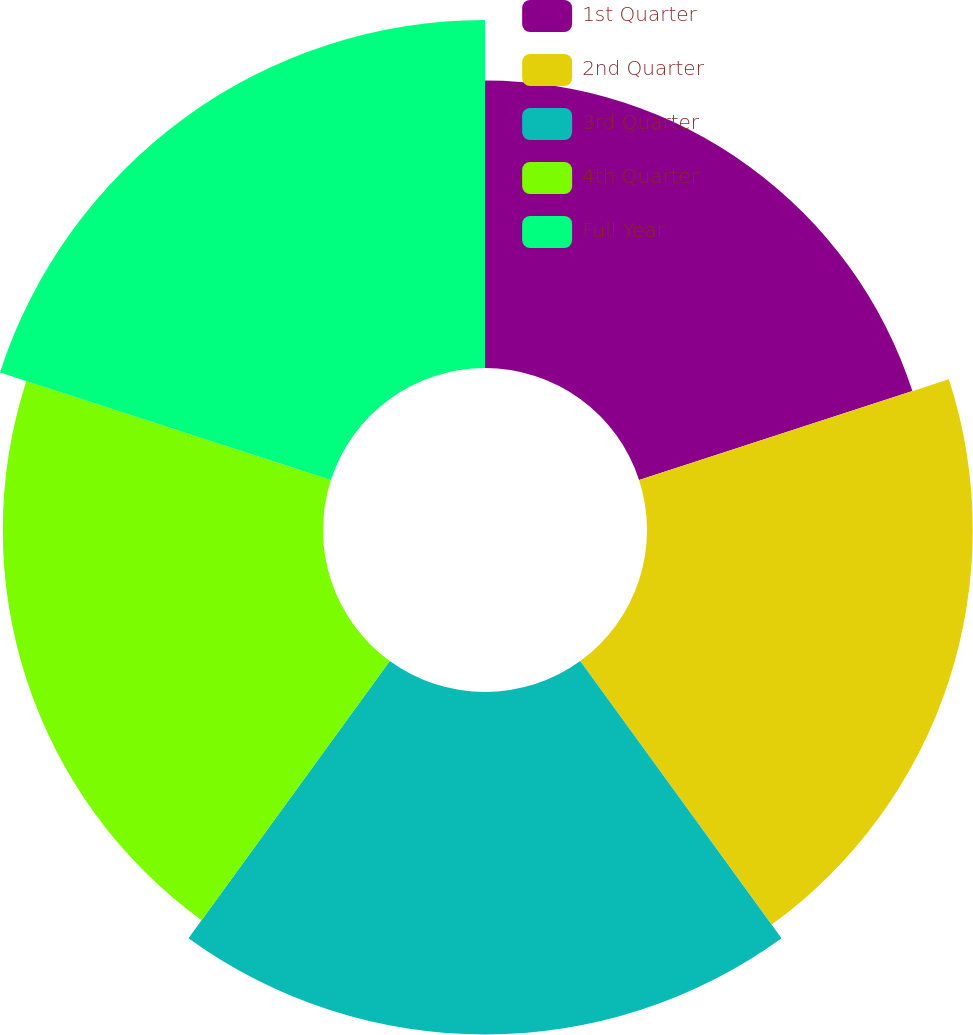Convert chart. <chart><loc_0><loc_0><loc_500><loc_500><pie_chart><fcel>1st Quarter<fcel>2nd Quarter<fcel>3rd Quarter<fcel>4th Quarter<fcel>Full Year<nl><fcel>17.7%<fcel>20.06%<fcel>21.09%<fcel>19.72%<fcel>21.43%<nl></chart> 